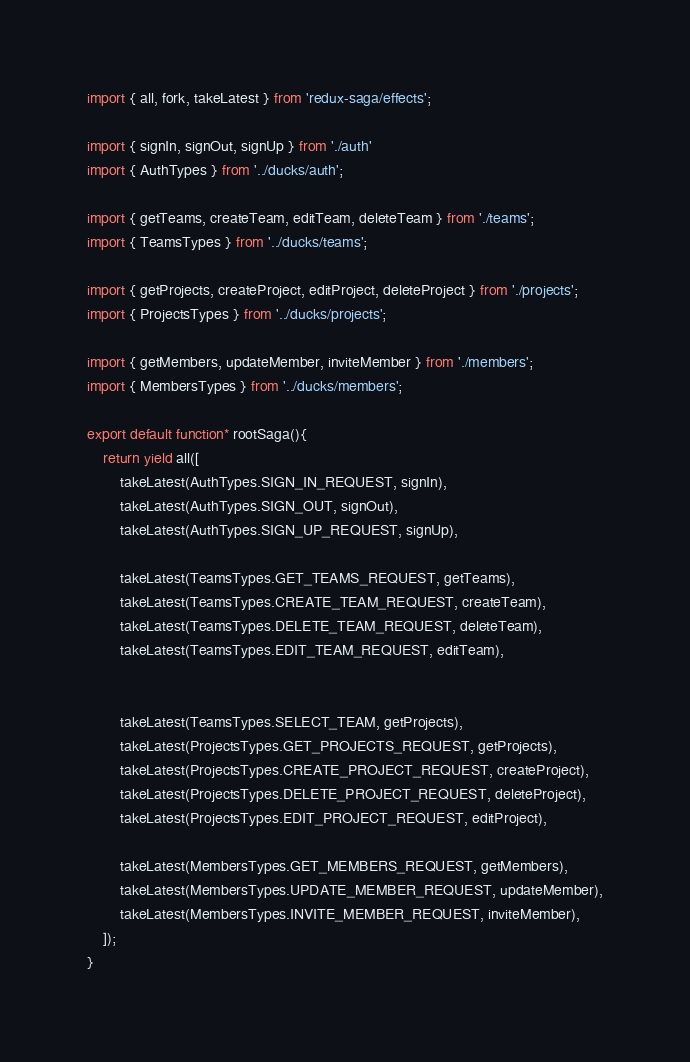Convert code to text. <code><loc_0><loc_0><loc_500><loc_500><_JavaScript_>import { all, fork, takeLatest } from 'redux-saga/effects';

import { signIn, signOut, signUp } from './auth'
import { AuthTypes } from '../ducks/auth';

import { getTeams, createTeam, editTeam, deleteTeam } from './teams';
import { TeamsTypes } from '../ducks/teams';

import { getProjects, createProject, editProject, deleteProject } from './projects';
import { ProjectsTypes } from '../ducks/projects';

import { getMembers, updateMember, inviteMember } from './members';
import { MembersTypes } from '../ducks/members';

export default function* rootSaga(){
    return yield all([
        takeLatest(AuthTypes.SIGN_IN_REQUEST, signIn),
        takeLatest(AuthTypes.SIGN_OUT, signOut),
        takeLatest(AuthTypes.SIGN_UP_REQUEST, signUp),

        takeLatest(TeamsTypes.GET_TEAMS_REQUEST, getTeams),
        takeLatest(TeamsTypes.CREATE_TEAM_REQUEST, createTeam),
        takeLatest(TeamsTypes.DELETE_TEAM_REQUEST, deleteTeam),
        takeLatest(TeamsTypes.EDIT_TEAM_REQUEST, editTeam),

        
        takeLatest(TeamsTypes.SELECT_TEAM, getProjects),
        takeLatest(ProjectsTypes.GET_PROJECTS_REQUEST, getProjects),
        takeLatest(ProjectsTypes.CREATE_PROJECT_REQUEST, createProject),
        takeLatest(ProjectsTypes.DELETE_PROJECT_REQUEST, deleteProject),
        takeLatest(ProjectsTypes.EDIT_PROJECT_REQUEST, editProject),

        takeLatest(MembersTypes.GET_MEMBERS_REQUEST, getMembers),
        takeLatest(MembersTypes.UPDATE_MEMBER_REQUEST, updateMember),
        takeLatest(MembersTypes.INVITE_MEMBER_REQUEST, inviteMember),
    ]);
}</code> 